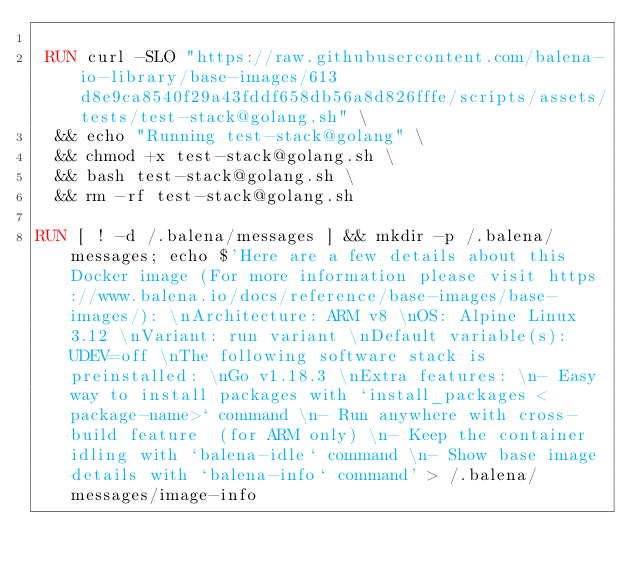Convert code to text. <code><loc_0><loc_0><loc_500><loc_500><_Dockerfile_>
 RUN curl -SLO "https://raw.githubusercontent.com/balena-io-library/base-images/613d8e9ca8540f29a43fddf658db56a8d826fffe/scripts/assets/tests/test-stack@golang.sh" \
  && echo "Running test-stack@golang" \
  && chmod +x test-stack@golang.sh \
  && bash test-stack@golang.sh \
  && rm -rf test-stack@golang.sh 

RUN [ ! -d /.balena/messages ] && mkdir -p /.balena/messages; echo $'Here are a few details about this Docker image (For more information please visit https://www.balena.io/docs/reference/base-images/base-images/): \nArchitecture: ARM v8 \nOS: Alpine Linux 3.12 \nVariant: run variant \nDefault variable(s): UDEV=off \nThe following software stack is preinstalled: \nGo v1.18.3 \nExtra features: \n- Easy way to install packages with `install_packages <package-name>` command \n- Run anywhere with cross-build feature  (for ARM only) \n- Keep the container idling with `balena-idle` command \n- Show base image details with `balena-info` command' > /.balena/messages/image-info</code> 